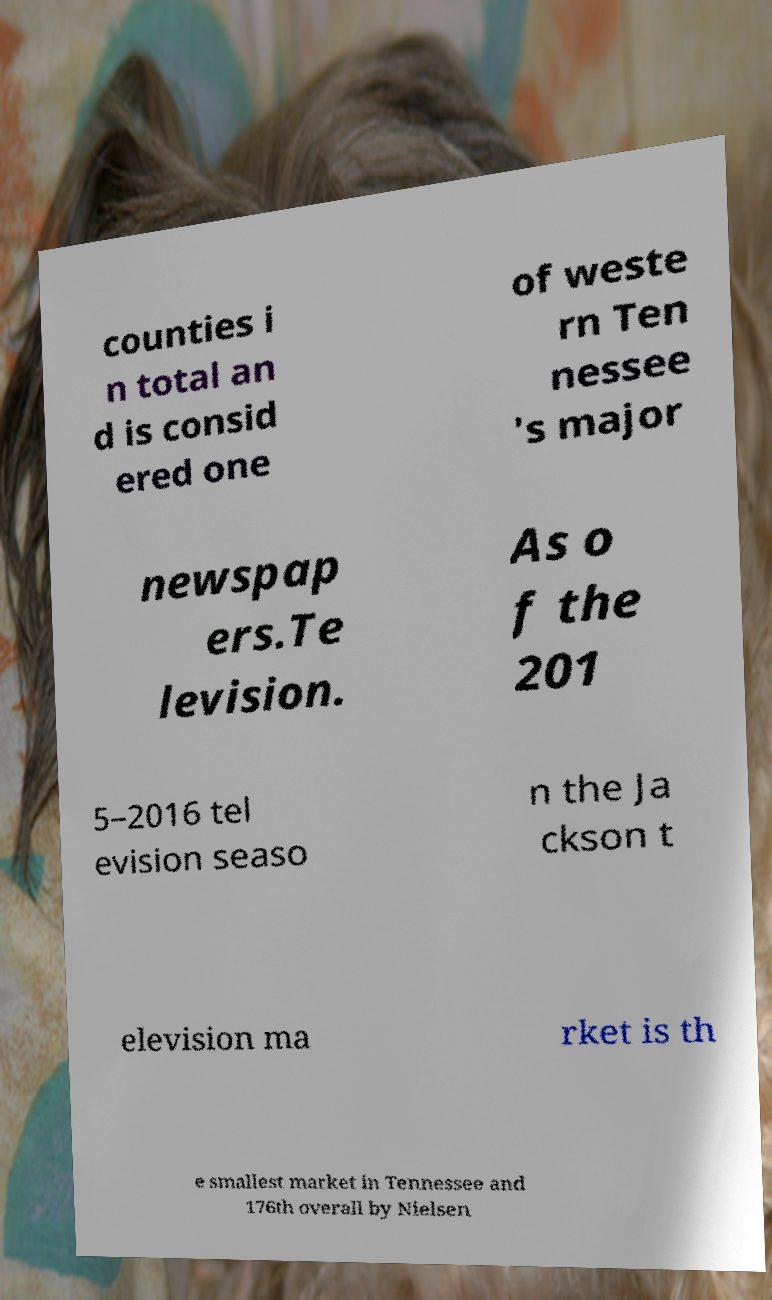There's text embedded in this image that I need extracted. Can you transcribe it verbatim? counties i n total an d is consid ered one of weste rn Ten nessee 's major newspap ers.Te levision. As o f the 201 5–2016 tel evision seaso n the Ja ckson t elevision ma rket is th e smallest market in Tennessee and 176th overall by Nielsen 